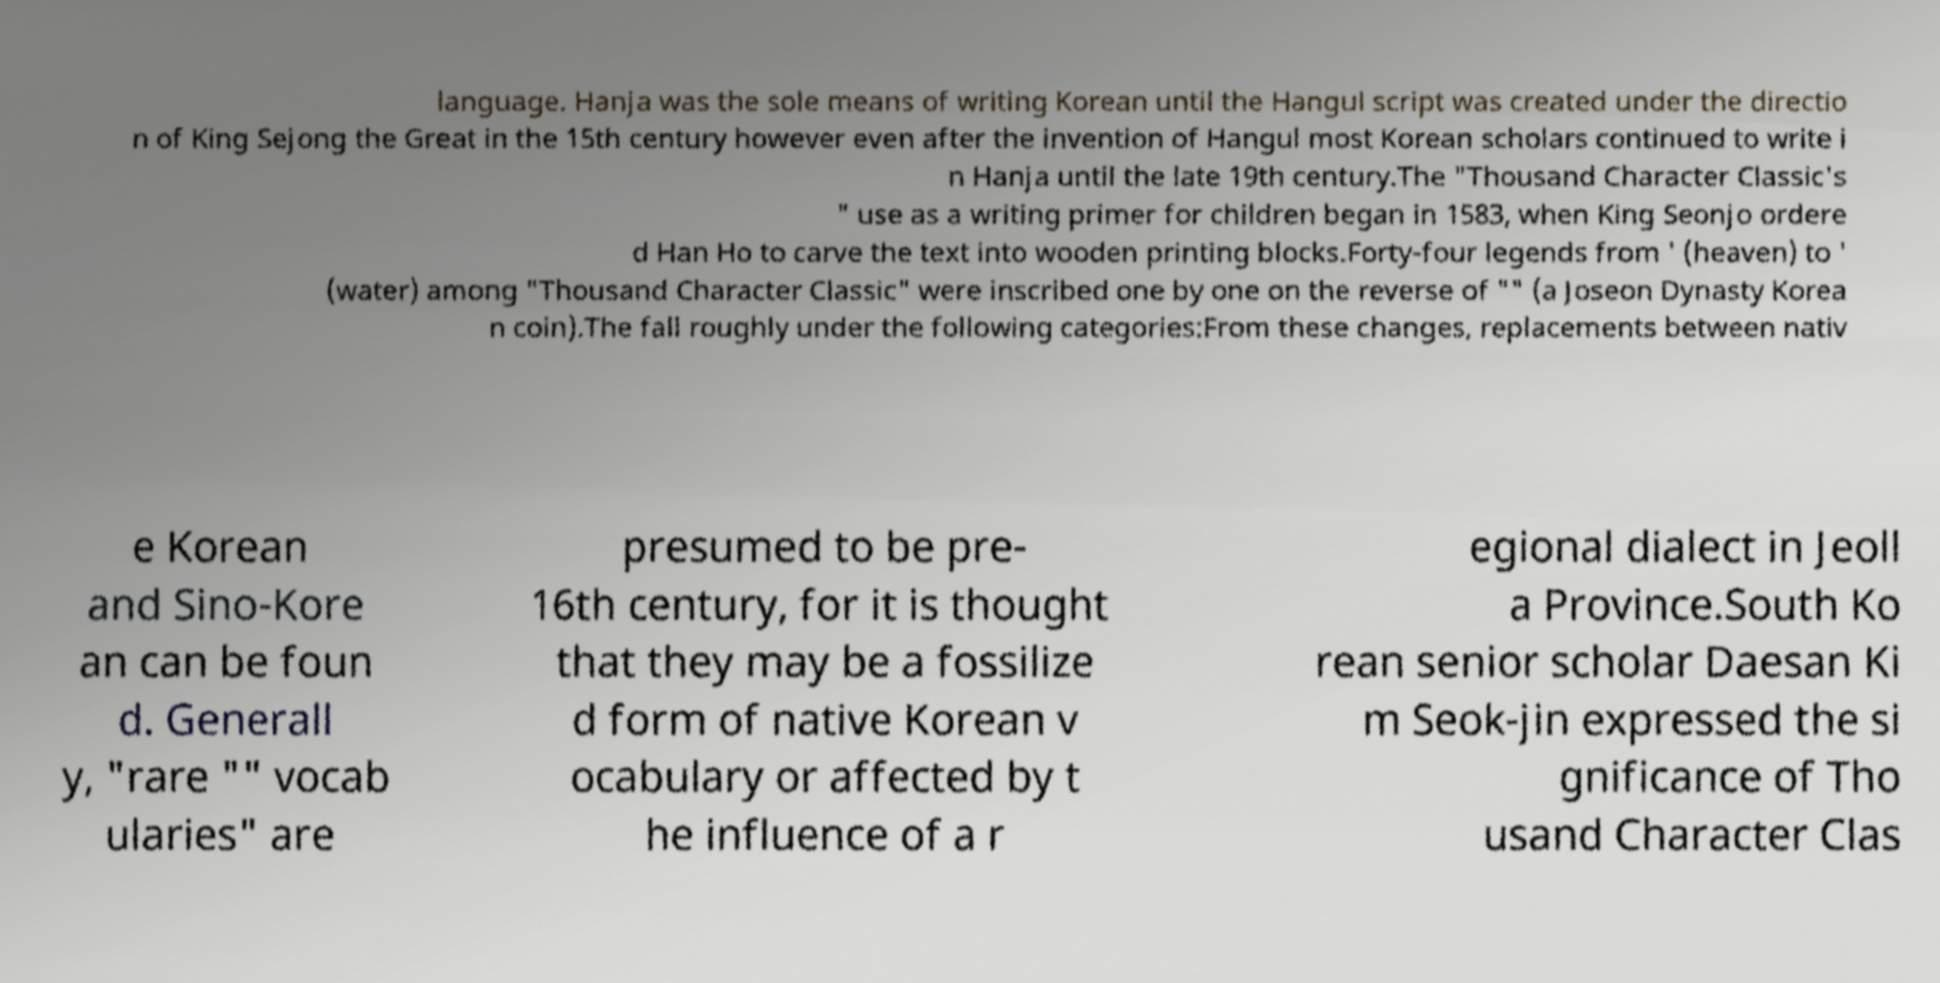Please identify and transcribe the text found in this image. language. Hanja was the sole means of writing Korean until the Hangul script was created under the directio n of King Sejong the Great in the 15th century however even after the invention of Hangul most Korean scholars continued to write i n Hanja until the late 19th century.The "Thousand Character Classic's " use as a writing primer for children began in 1583, when King Seonjo ordere d Han Ho to carve the text into wooden printing blocks.Forty-four legends from ' (heaven) to ' (water) among "Thousand Character Classic" were inscribed one by one on the reverse of "" (a Joseon Dynasty Korea n coin).The fall roughly under the following categories:From these changes, replacements between nativ e Korean and Sino-Kore an can be foun d. Generall y, "rare "" vocab ularies" are presumed to be pre- 16th century, for it is thought that they may be a fossilize d form of native Korean v ocabulary or affected by t he influence of a r egional dialect in Jeoll a Province.South Ko rean senior scholar Daesan Ki m Seok-jin expressed the si gnificance of Tho usand Character Clas 